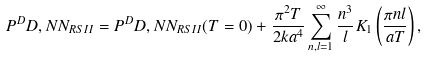<formula> <loc_0><loc_0><loc_500><loc_500>P ^ { D } D , N N _ { R S I I } = P ^ { D } D , N N _ { R S I I } ( T = 0 ) + \frac { \pi ^ { 2 } T } { 2 k a ^ { 4 } } \sum _ { n , l = 1 } ^ { \infty } \frac { n ^ { 3 } } { l } K _ { 1 } \left ( \frac { \pi n l } { a T } \right ) ,</formula> 